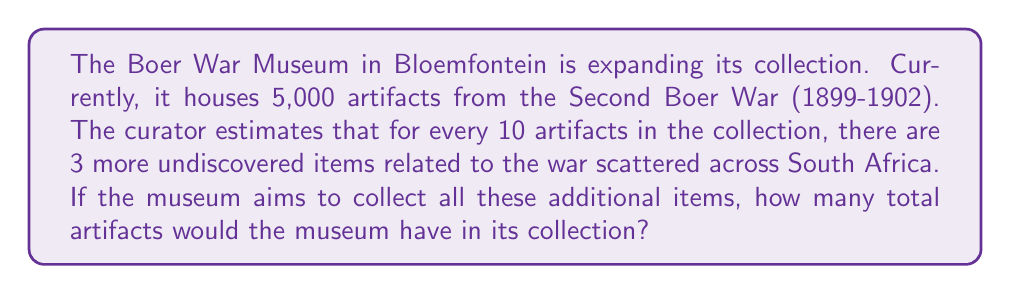Can you solve this math problem? Let's approach this problem step-by-step:

1) First, we need to determine the ratio of undiscovered artifacts to current artifacts:
   $\frac{3}{10}$ or $0.3$

2) This means that for every artifact in the museum, there are 0.3 undiscovered artifacts.

3) To find the number of undiscovered artifacts, we multiply the current number of artifacts by 0.3:
   $5,000 \times 0.3 = 1,500$

4) Now, to get the total number of artifacts after collecting all undiscovered items, we add this to the current number:
   $5,000 + 1,500 = 6,500$

Therefore, if the museum collects all the estimated undiscovered artifacts, it would have a total of 6,500 items in its collection.
Answer: 6,500 artifacts 